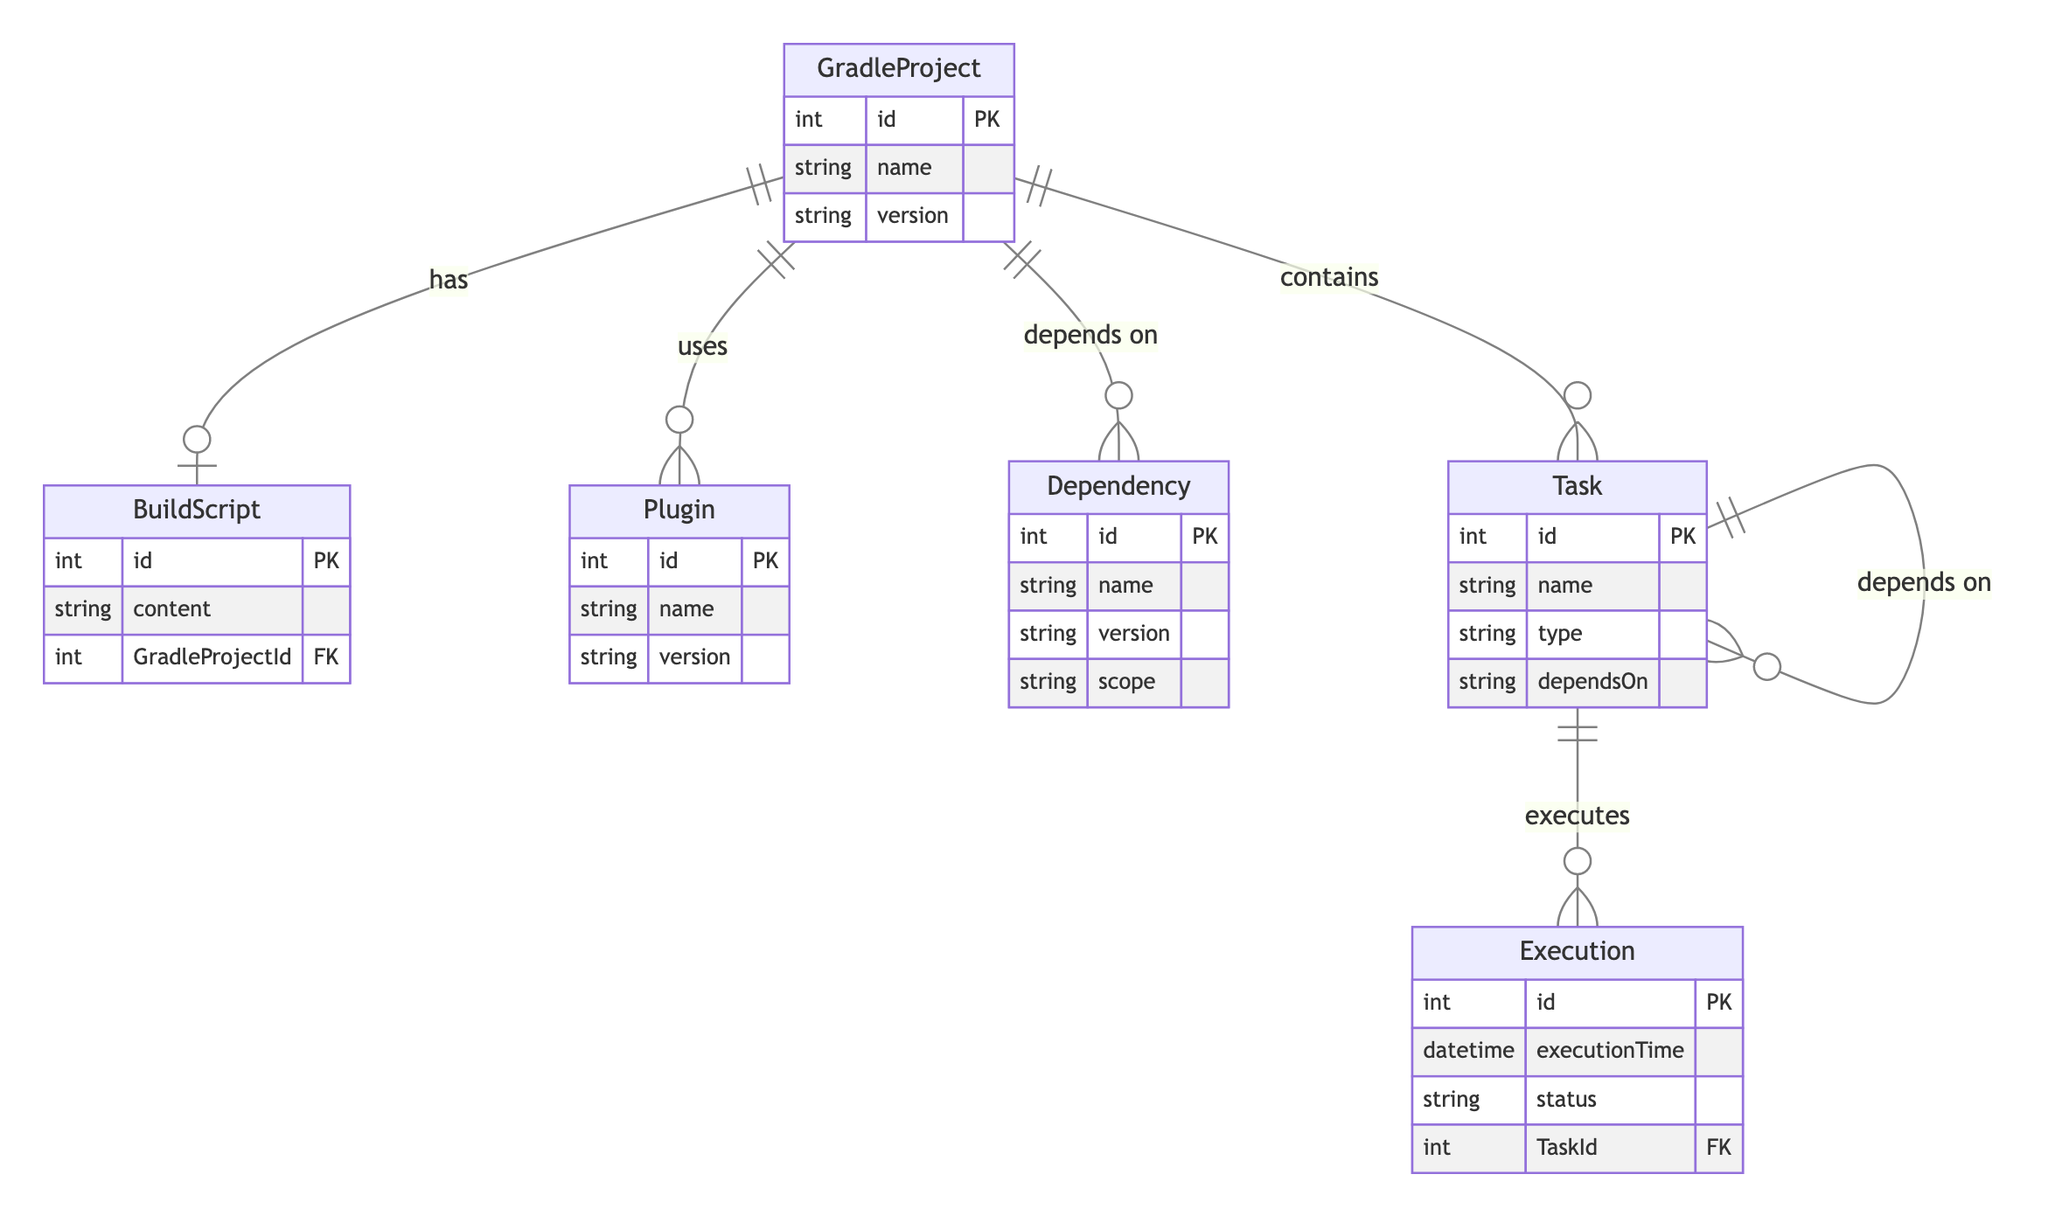What is the ID of the GradleProject entity? The GradleProject entity has an attribute named "id," which is specifically denoted as its primary key. Therefore, the ID of the GradleProject entity can be referred to as a unique integer assigned to it.
Answer: id How many attributes does the Task entity have? The Task entity has four attributes: "id," "name," "type," and "dependsOn." By counting these attributes, we find there are four in total.
Answer: four What relationship does a GradleProject have with the Dependency entity? The relationship between GradleProject and Dependency is identified as "depends on." This relationship connects the GradleProject entity to the Dependency entity and indicates a reliance on it.
Answer: depends on Which entities have a direct relationship with the Task entity? The Task entity has a direct relationship with Execution (executes) and itself (depends on). This means it can initiate executions and can depend on other tasks.
Answer: Execution and Task How many distinct relationships are depicted in the diagram? The diagram outlines six distinct relationships among the entities: GradleProject to BuildScript, GradleProject to Plugin, GradleProject to Dependency, GradleProject to Task, Task to Execution, and Task to Task. By counting these connections, we arrive at six.
Answer: six What is the scope attribute associated with the Dependency entity? The Dependency entity includes an attribute named "scope," which denotes the context or extent at which the dependency is applicable or used within the Gradle environment, representing how dependencies are categorized.
Answer: scope What is the primary key of the Execution entity? The Execution entity contains an attribute named "id," which is designated as its primary key (PK). This unique identifier allows the differentiation of each execution within the context of tasks.
Answer: id 